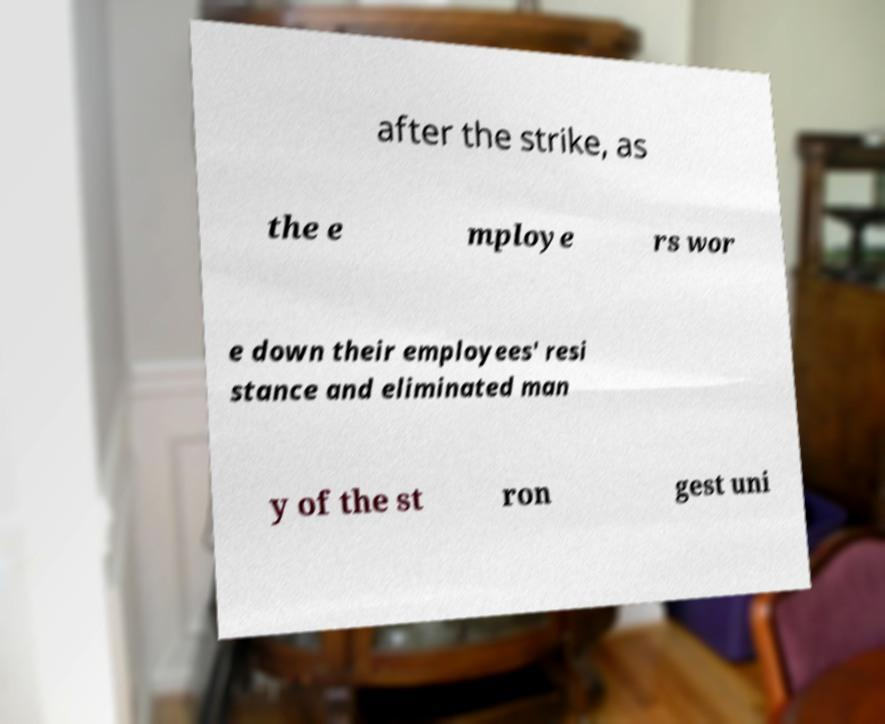I need the written content from this picture converted into text. Can you do that? after the strike, as the e mploye rs wor e down their employees' resi stance and eliminated man y of the st ron gest uni 